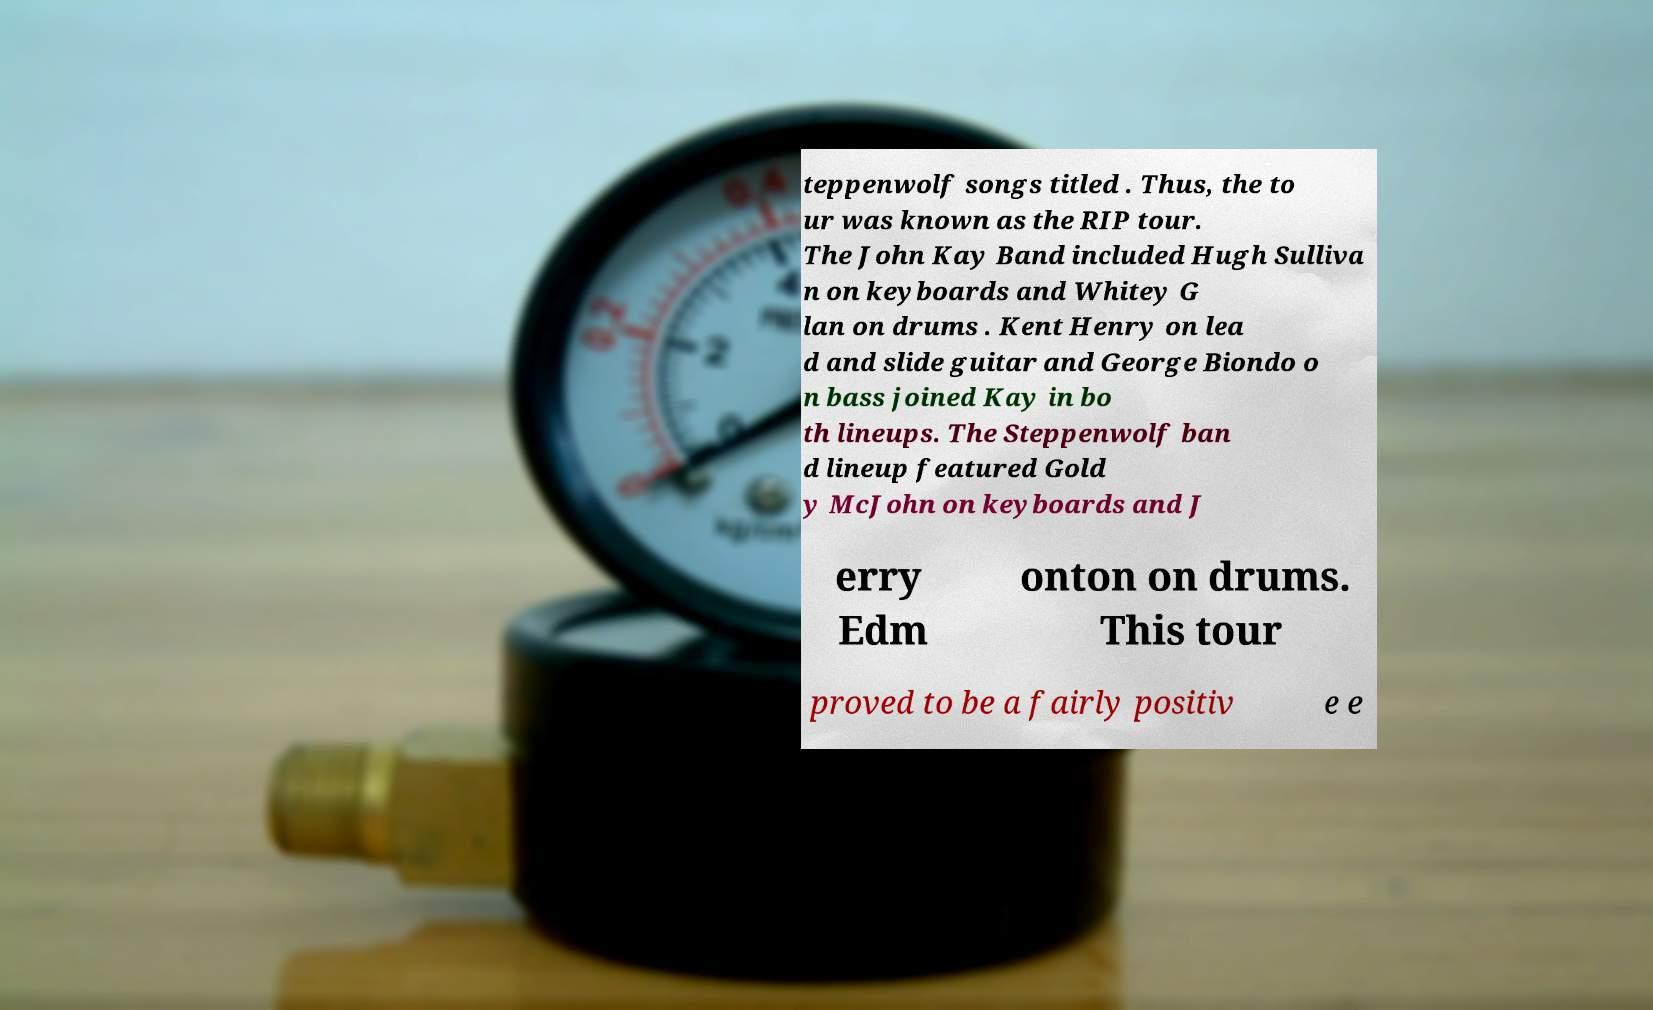Please read and relay the text visible in this image. What does it say? teppenwolf songs titled . Thus, the to ur was known as the RIP tour. The John Kay Band included Hugh Sulliva n on keyboards and Whitey G lan on drums . Kent Henry on lea d and slide guitar and George Biondo o n bass joined Kay in bo th lineups. The Steppenwolf ban d lineup featured Gold y McJohn on keyboards and J erry Edm onton on drums. This tour proved to be a fairly positiv e e 